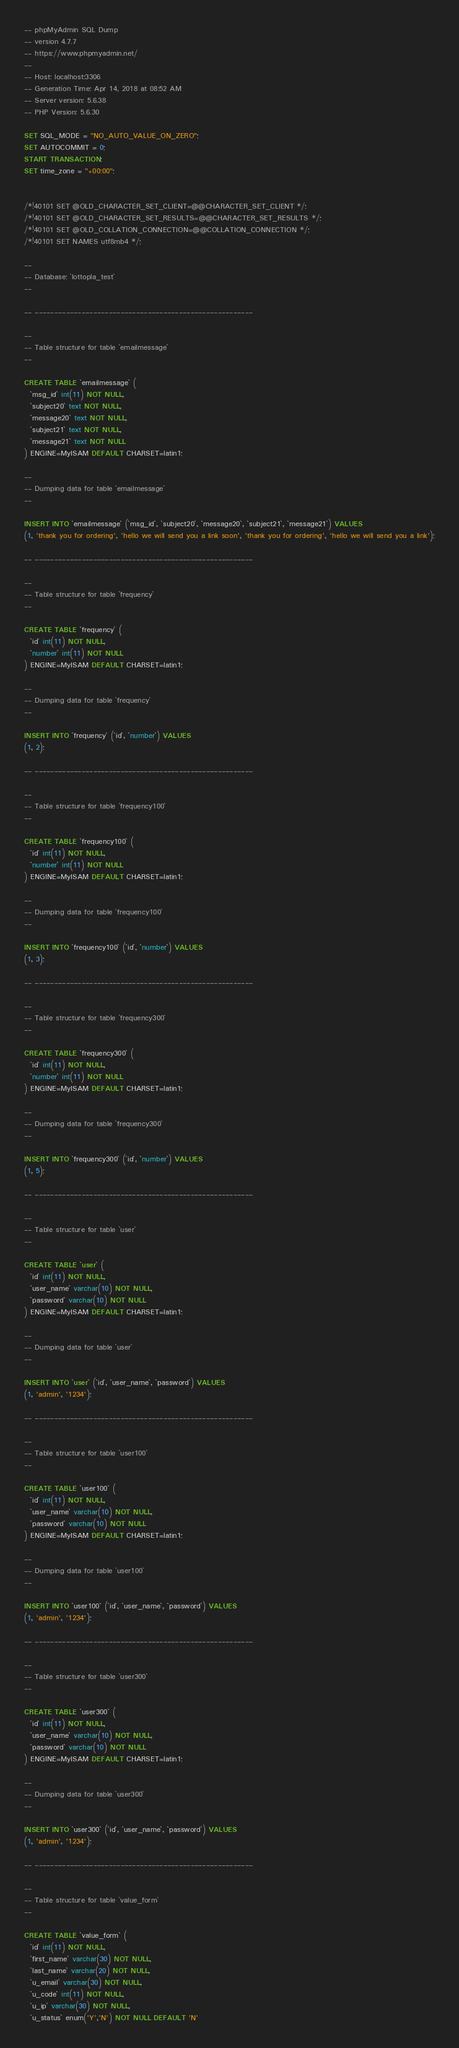<code> <loc_0><loc_0><loc_500><loc_500><_SQL_>-- phpMyAdmin SQL Dump
-- version 4.7.7
-- https://www.phpmyadmin.net/
--
-- Host: localhost:3306
-- Generation Time: Apr 14, 2018 at 08:52 AM
-- Server version: 5.6.38
-- PHP Version: 5.6.30

SET SQL_MODE = "NO_AUTO_VALUE_ON_ZERO";
SET AUTOCOMMIT = 0;
START TRANSACTION;
SET time_zone = "+00:00";


/*!40101 SET @OLD_CHARACTER_SET_CLIENT=@@CHARACTER_SET_CLIENT */;
/*!40101 SET @OLD_CHARACTER_SET_RESULTS=@@CHARACTER_SET_RESULTS */;
/*!40101 SET @OLD_COLLATION_CONNECTION=@@COLLATION_CONNECTION */;
/*!40101 SET NAMES utf8mb4 */;

--
-- Database: `lottopla_test`
--

-- --------------------------------------------------------

--
-- Table structure for table `emailmessage`
--

CREATE TABLE `emailmessage` (
  `msg_id` int(11) NOT NULL,
  `subject20` text NOT NULL,
  `message20` text NOT NULL,
  `subject21` text NOT NULL,
  `message21` text NOT NULL
) ENGINE=MyISAM DEFAULT CHARSET=latin1;

--
-- Dumping data for table `emailmessage`
--

INSERT INTO `emailmessage` (`msg_id`, `subject20`, `message20`, `subject21`, `message21`) VALUES
(1, 'thank you for ordering', 'hello we will send you a link soon', 'thank you for ordering', 'hello we will send you a link');

-- --------------------------------------------------------

--
-- Table structure for table `frequency`
--

CREATE TABLE `frequency` (
  `id` int(11) NOT NULL,
  `number` int(11) NOT NULL
) ENGINE=MyISAM DEFAULT CHARSET=latin1;

--
-- Dumping data for table `frequency`
--

INSERT INTO `frequency` (`id`, `number`) VALUES
(1, 2);

-- --------------------------------------------------------

--
-- Table structure for table `frequency100`
--

CREATE TABLE `frequency100` (
  `id` int(11) NOT NULL,
  `number` int(11) NOT NULL
) ENGINE=MyISAM DEFAULT CHARSET=latin1;

--
-- Dumping data for table `frequency100`
--

INSERT INTO `frequency100` (`id`, `number`) VALUES
(1, 3);

-- --------------------------------------------------------

--
-- Table structure for table `frequency300`
--

CREATE TABLE `frequency300` (
  `id` int(11) NOT NULL,
  `number` int(11) NOT NULL
) ENGINE=MyISAM DEFAULT CHARSET=latin1;

--
-- Dumping data for table `frequency300`
--

INSERT INTO `frequency300` (`id`, `number`) VALUES
(1, 5);

-- --------------------------------------------------------

--
-- Table structure for table `user`
--

CREATE TABLE `user` (
  `id` int(11) NOT NULL,
  `user_name` varchar(10) NOT NULL,
  `password` varchar(10) NOT NULL
) ENGINE=MyISAM DEFAULT CHARSET=latin1;

--
-- Dumping data for table `user`
--

INSERT INTO `user` (`id`, `user_name`, `password`) VALUES
(1, 'admin', '1234');

-- --------------------------------------------------------

--
-- Table structure for table `user100`
--

CREATE TABLE `user100` (
  `id` int(11) NOT NULL,
  `user_name` varchar(10) NOT NULL,
  `password` varchar(10) NOT NULL
) ENGINE=MyISAM DEFAULT CHARSET=latin1;

--
-- Dumping data for table `user100`
--

INSERT INTO `user100` (`id`, `user_name`, `password`) VALUES
(1, 'admin', '1234');

-- --------------------------------------------------------

--
-- Table structure for table `user300`
--

CREATE TABLE `user300` (
  `id` int(11) NOT NULL,
  `user_name` varchar(10) NOT NULL,
  `password` varchar(10) NOT NULL
) ENGINE=MyISAM DEFAULT CHARSET=latin1;

--
-- Dumping data for table `user300`
--

INSERT INTO `user300` (`id`, `user_name`, `password`) VALUES
(1, 'admin', '1234');

-- --------------------------------------------------------

--
-- Table structure for table `value_form`
--

CREATE TABLE `value_form` (
  `id` int(11) NOT NULL,
  `first_name` varchar(30) NOT NULL,
  `last_name` varchar(20) NOT NULL,
  `u_email` varchar(30) NOT NULL,
  `u_code` int(11) NOT NULL,
  `u_ip` varchar(30) NOT NULL,
  `u_status` enum('Y','N') NOT NULL DEFAULT 'N'</code> 